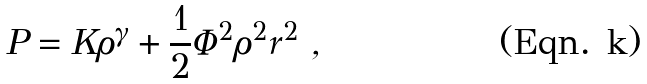<formula> <loc_0><loc_0><loc_500><loc_500>P = K \rho ^ { \gamma } + \frac { 1 } { 2 } \Phi ^ { 2 } \rho ^ { 2 } r ^ { 2 } \ ,</formula> 